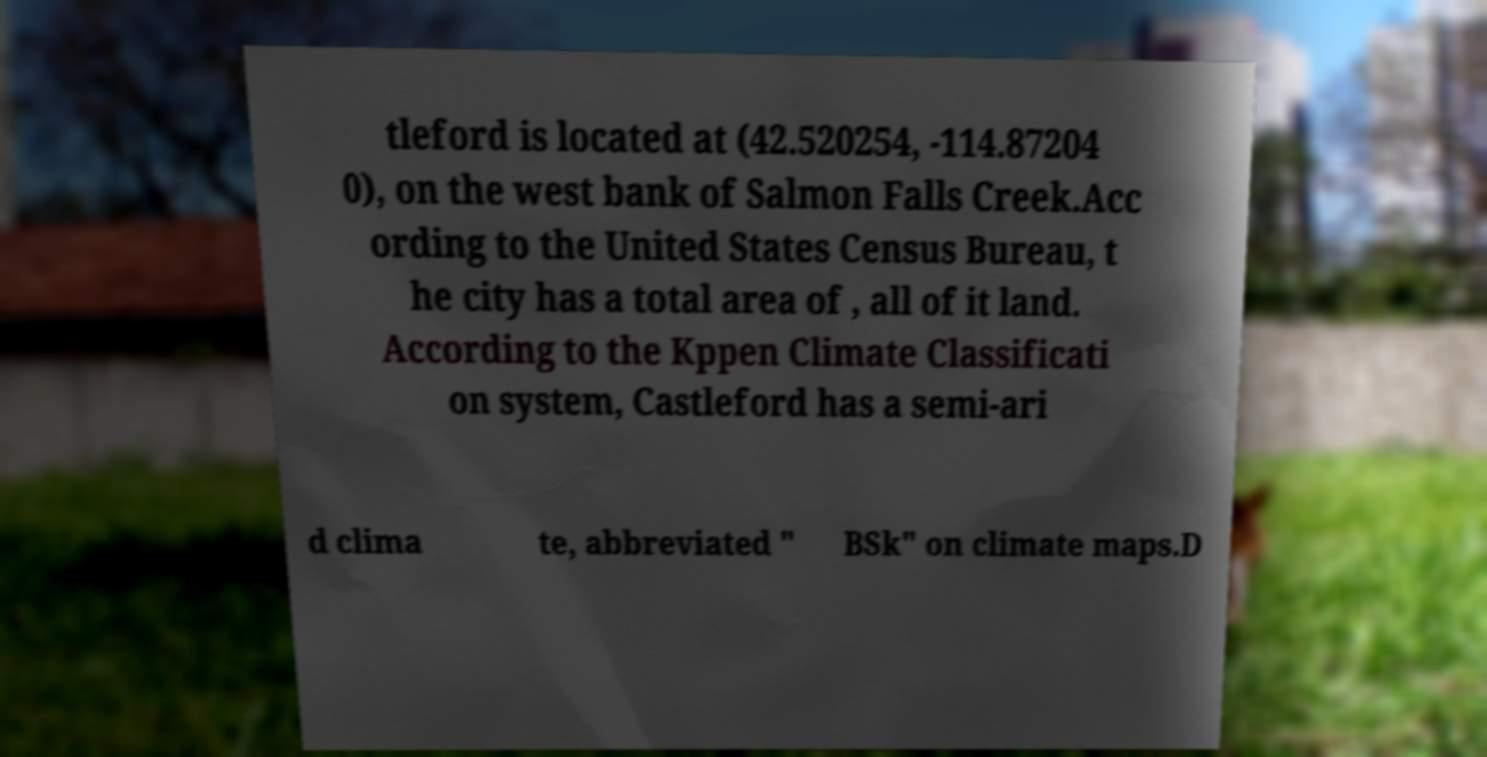Can you read and provide the text displayed in the image?This photo seems to have some interesting text. Can you extract and type it out for me? tleford is located at (42.520254, -114.87204 0), on the west bank of Salmon Falls Creek.Acc ording to the United States Census Bureau, t he city has a total area of , all of it land. According to the Kppen Climate Classificati on system, Castleford has a semi-ari d clima te, abbreviated " BSk" on climate maps.D 